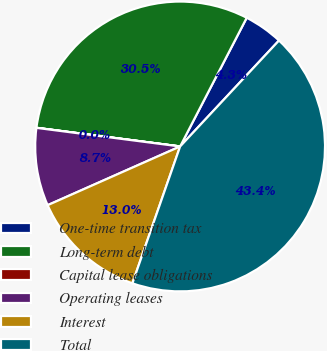<chart> <loc_0><loc_0><loc_500><loc_500><pie_chart><fcel>One-time transition tax<fcel>Long-term debt<fcel>Capital lease obligations<fcel>Operating leases<fcel>Interest<fcel>Total<nl><fcel>4.35%<fcel>30.54%<fcel>0.01%<fcel>8.69%<fcel>13.02%<fcel>43.39%<nl></chart> 